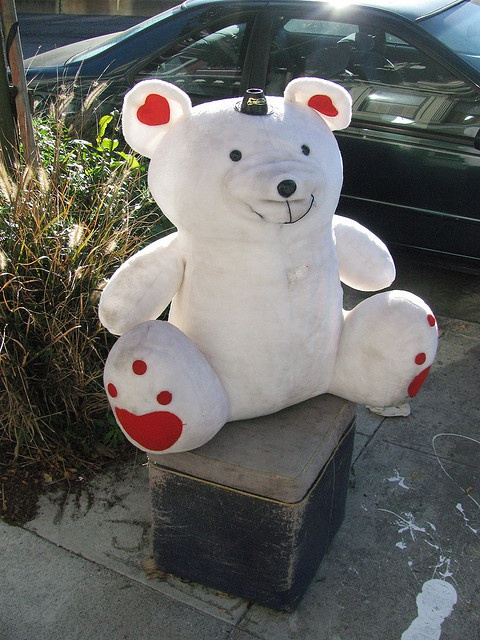Describe the objects in this image and their specific colors. I can see teddy bear in black, darkgray, and lightgray tones and car in black, gray, purple, and navy tones in this image. 